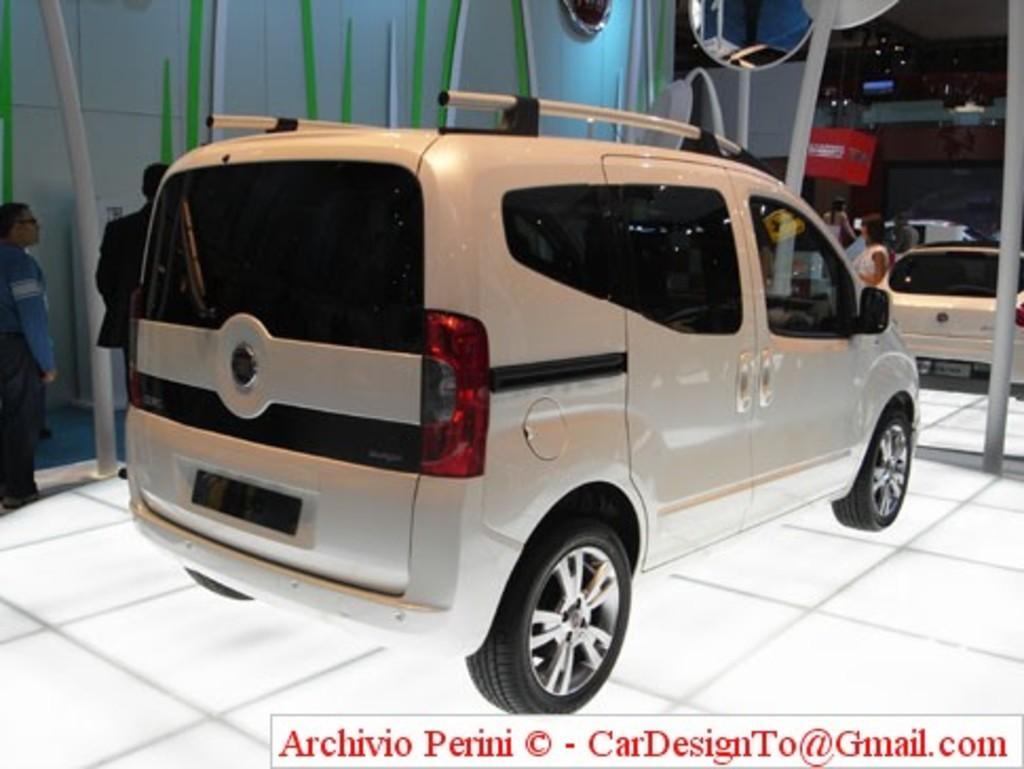Could you give a brief overview of what you see in this image? In this picture I can see couple of cars and few people standing and I can see a mirror to the pole and text at the bottom right corner of the picture. 